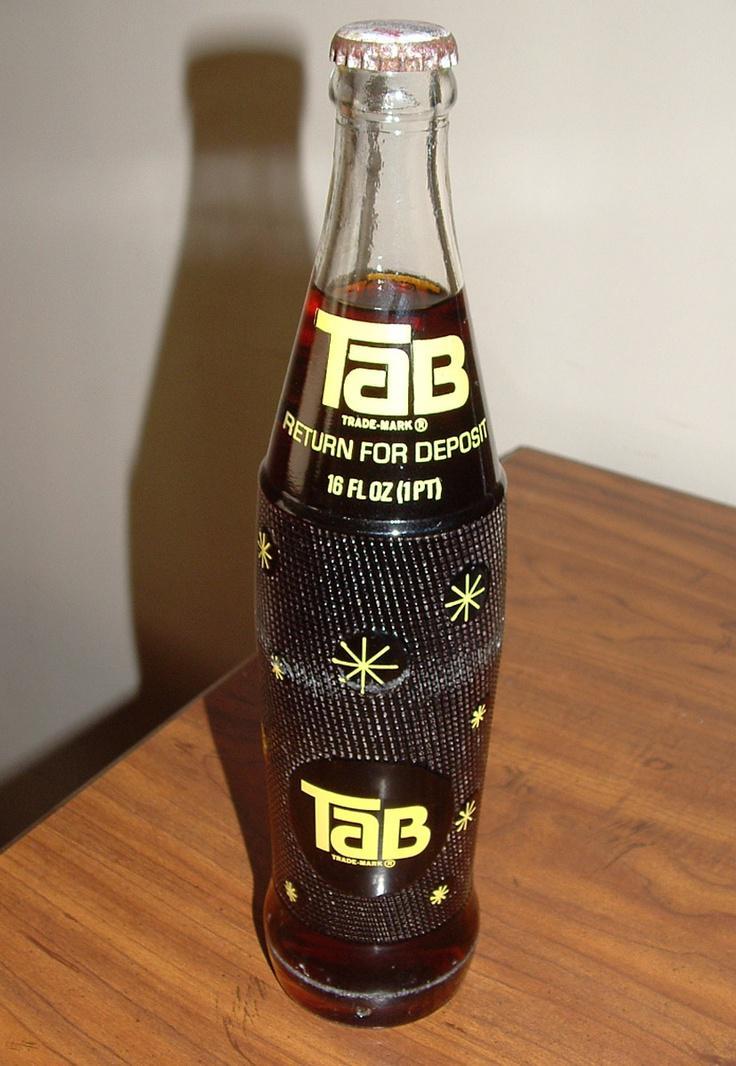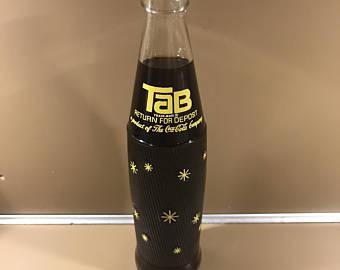The first image is the image on the left, the second image is the image on the right. Given the left and right images, does the statement "The right image contains one glass bottle with a dark colored liquid inside." hold true? Answer yes or no. Yes. The first image is the image on the left, the second image is the image on the right. Analyze the images presented: Is the assertion "One image shows an empty upright bottle with no cap, and the other shows a bottle of dark liquid with a cap on it." valid? Answer yes or no. No. 